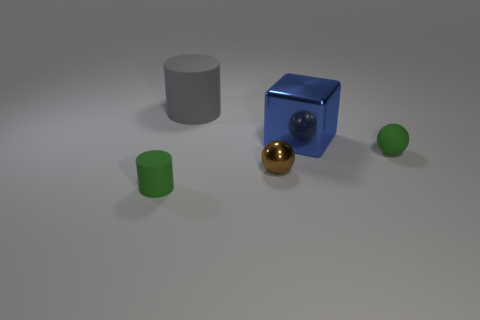Add 3 blocks. How many objects exist? 8 Subtract all spheres. How many objects are left? 3 Add 2 tiny green cylinders. How many tiny green cylinders exist? 3 Subtract 1 gray cylinders. How many objects are left? 4 Subtract all brown spheres. Subtract all green cylinders. How many objects are left? 3 Add 2 small green cylinders. How many small green cylinders are left? 3 